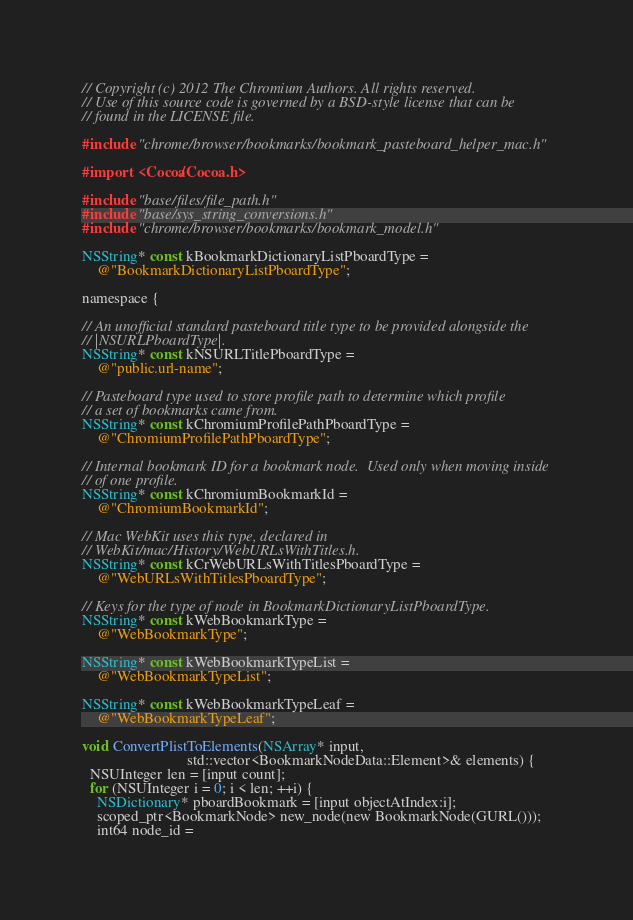<code> <loc_0><loc_0><loc_500><loc_500><_ObjectiveC_>// Copyright (c) 2012 The Chromium Authors. All rights reserved.
// Use of this source code is governed by a BSD-style license that can be
// found in the LICENSE file.

#include "chrome/browser/bookmarks/bookmark_pasteboard_helper_mac.h"

#import <Cocoa/Cocoa.h>

#include "base/files/file_path.h"
#include "base/sys_string_conversions.h"
#include "chrome/browser/bookmarks/bookmark_model.h"

NSString* const kBookmarkDictionaryListPboardType =
    @"BookmarkDictionaryListPboardType";

namespace {

// An unofficial standard pasteboard title type to be provided alongside the
// |NSURLPboardType|.
NSString* const kNSURLTitlePboardType =
    @"public.url-name";

// Pasteboard type used to store profile path to determine which profile
// a set of bookmarks came from.
NSString* const kChromiumProfilePathPboardType =
    @"ChromiumProfilePathPboardType";

// Internal bookmark ID for a bookmark node.  Used only when moving inside
// of one profile.
NSString* const kChromiumBookmarkId =
    @"ChromiumBookmarkId";

// Mac WebKit uses this type, declared in
// WebKit/mac/History/WebURLsWithTitles.h.
NSString* const kCrWebURLsWithTitlesPboardType =
    @"WebURLsWithTitlesPboardType";

// Keys for the type of node in BookmarkDictionaryListPboardType.
NSString* const kWebBookmarkType =
    @"WebBookmarkType";

NSString* const kWebBookmarkTypeList =
    @"WebBookmarkTypeList";

NSString* const kWebBookmarkTypeLeaf =
    @"WebBookmarkTypeLeaf";

void ConvertPlistToElements(NSArray* input,
                            std::vector<BookmarkNodeData::Element>& elements) {
  NSUInteger len = [input count];
  for (NSUInteger i = 0; i < len; ++i) {
    NSDictionary* pboardBookmark = [input objectAtIndex:i];
    scoped_ptr<BookmarkNode> new_node(new BookmarkNode(GURL()));
    int64 node_id =</code> 